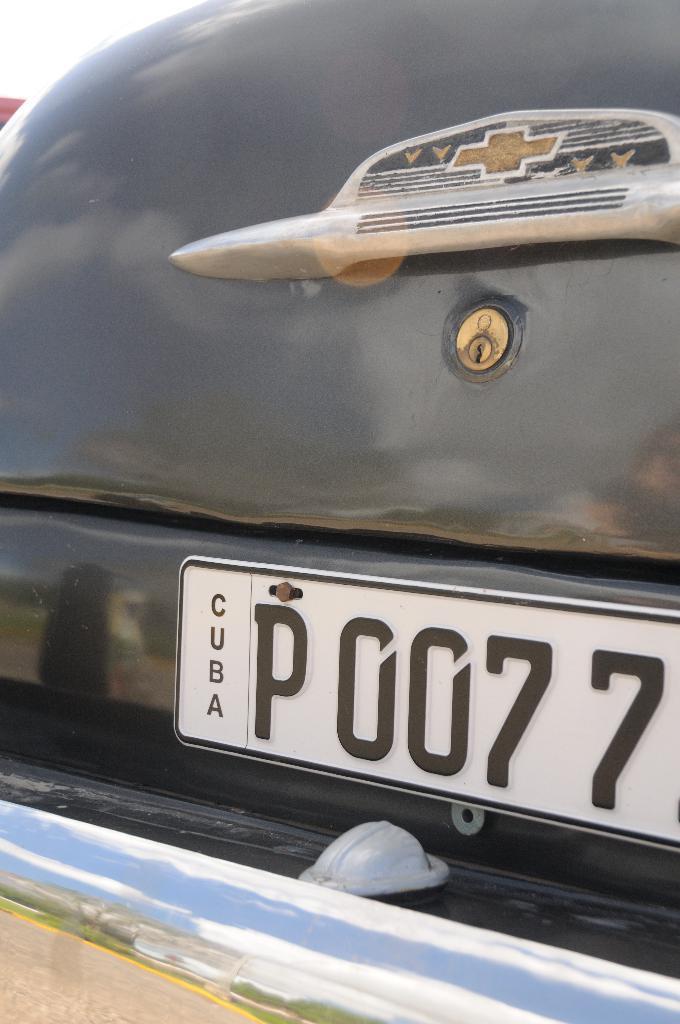Could you give a brief overview of what you see in this image? This image consists of a car in black color. In the front, we can see the boot of the car along with number plate. 